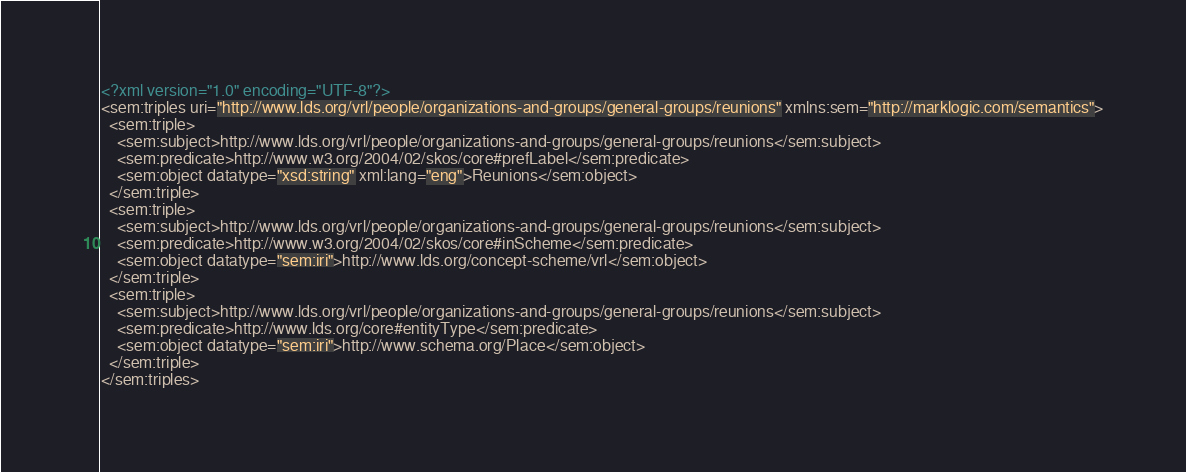<code> <loc_0><loc_0><loc_500><loc_500><_XML_><?xml version="1.0" encoding="UTF-8"?>
<sem:triples uri="http://www.lds.org/vrl/people/organizations-and-groups/general-groups/reunions" xmlns:sem="http://marklogic.com/semantics">
  <sem:triple>
    <sem:subject>http://www.lds.org/vrl/people/organizations-and-groups/general-groups/reunions</sem:subject>
    <sem:predicate>http://www.w3.org/2004/02/skos/core#prefLabel</sem:predicate>
    <sem:object datatype="xsd:string" xml:lang="eng">Reunions</sem:object>
  </sem:triple>
  <sem:triple>
    <sem:subject>http://www.lds.org/vrl/people/organizations-and-groups/general-groups/reunions</sem:subject>
    <sem:predicate>http://www.w3.org/2004/02/skos/core#inScheme</sem:predicate>
    <sem:object datatype="sem:iri">http://www.lds.org/concept-scheme/vrl</sem:object>
  </sem:triple>
  <sem:triple>
    <sem:subject>http://www.lds.org/vrl/people/organizations-and-groups/general-groups/reunions</sem:subject>
    <sem:predicate>http://www.lds.org/core#entityType</sem:predicate>
    <sem:object datatype="sem:iri">http://www.schema.org/Place</sem:object>
  </sem:triple>
</sem:triples>
</code> 